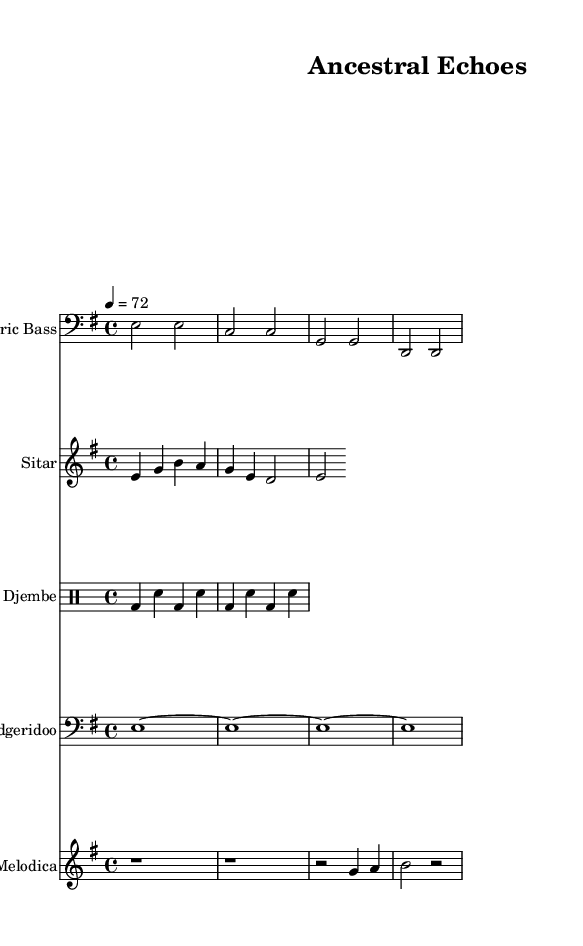What is the key signature of this music? The key signature is indicated by the sharp or flat symbols at the beginning of the staff. Here, there are no sharps or flats shown. Thus, the piece is in E minor.
Answer: E minor What is the time signature of this piece? The time signature is shown as a fraction at the beginning of the score. It appears as 4/4, which indicates four beats per measure and a quarter note receives one beat.
Answer: 4/4 What is the tempo marking for this music? The tempo is marked with a number and note value at the beginning. In this case, it indicates a tempo of 72 beats per minute.
Answer: 72 How many measures does the djembe part have? The djembe part shows four measures of rhythmic patterns, with each measure containing a set number of beats. Counting the measures in the staff, I can see there are four.
Answer: 4 Which traditional instrument has the longest note value in this score? The didgeridoo part consists of notes that are sustained for the entire measure, denoted with the tied notes (the horizontal line), meaning it holds one long note per measure. Compare this with other instruments and it is clear, the didgeridoo has a longer note duration.
Answer: Didgeridoo What folk instrument is used in this reggae track? The score includes a sitar as one of the instruments, which is a traditional folk instrument from South Asia. The other instruments listed are also folk or culturally significant.
Answer: Sitar How many different types of instruments are used in this piece? The score lists five distinct instrument parts: electric bass, sitar, djembe, didgeridoo, and melodica. Counting these, we confirm there are five different types represented.
Answer: 5 